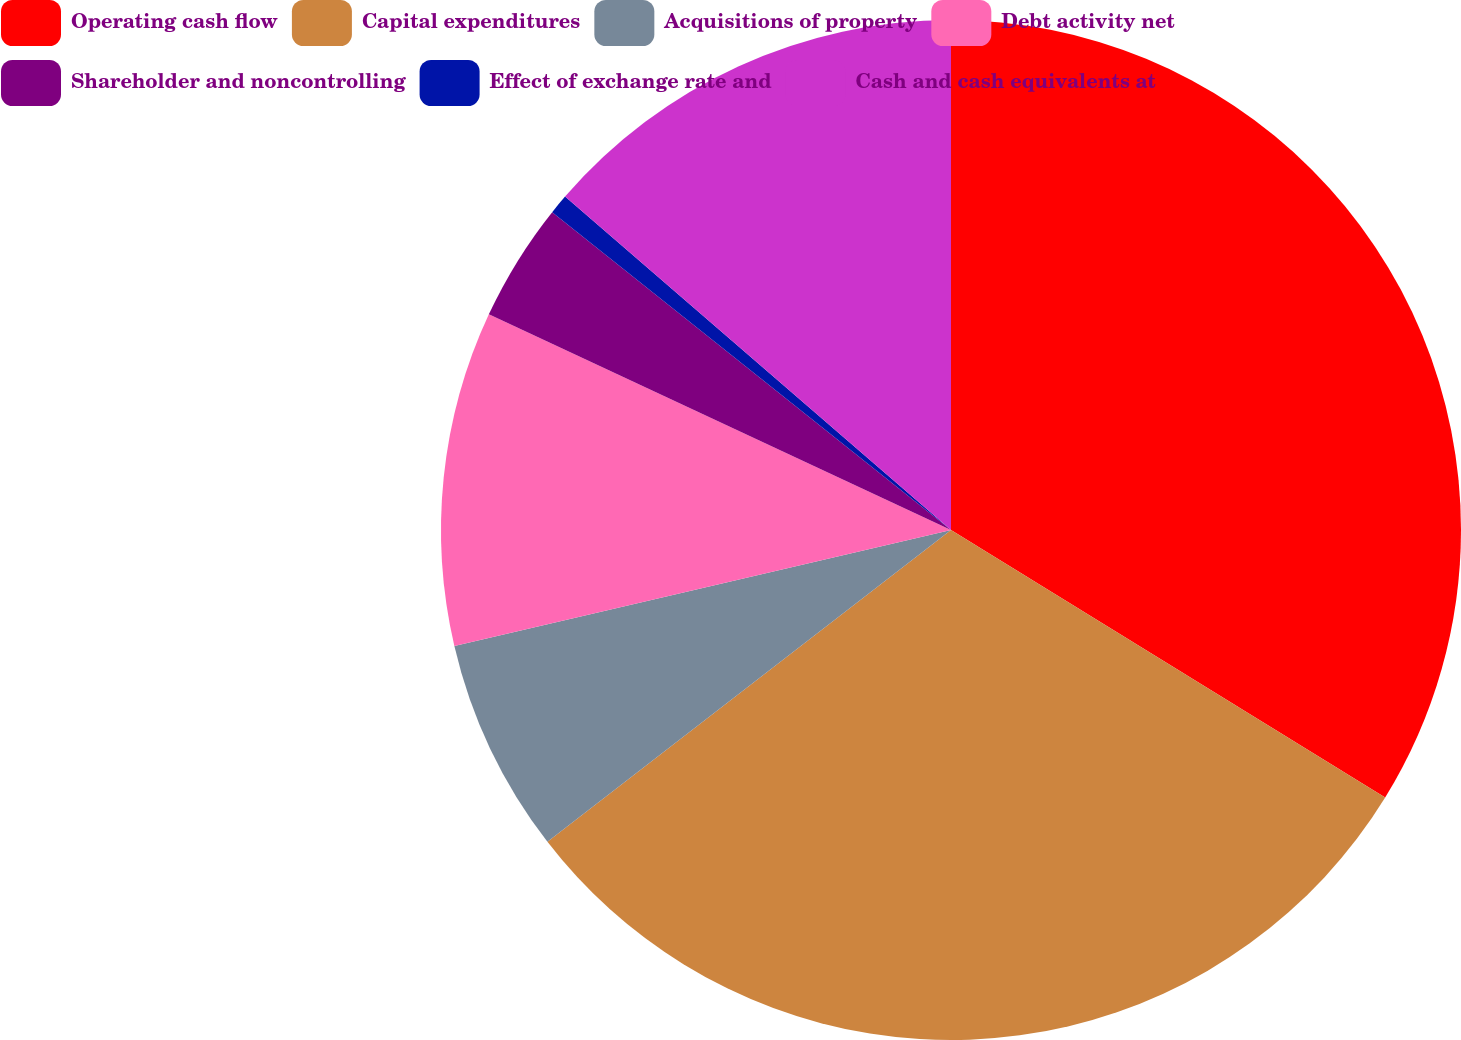<chart> <loc_0><loc_0><loc_500><loc_500><pie_chart><fcel>Operating cash flow<fcel>Capital expenditures<fcel>Acquisitions of property<fcel>Debt activity net<fcel>Shareholder and noncontrolling<fcel>Effect of exchange rate and<fcel>Cash and cash equivalents at<nl><fcel>33.79%<fcel>30.74%<fcel>6.82%<fcel>10.6%<fcel>3.76%<fcel>0.63%<fcel>13.66%<nl></chart> 